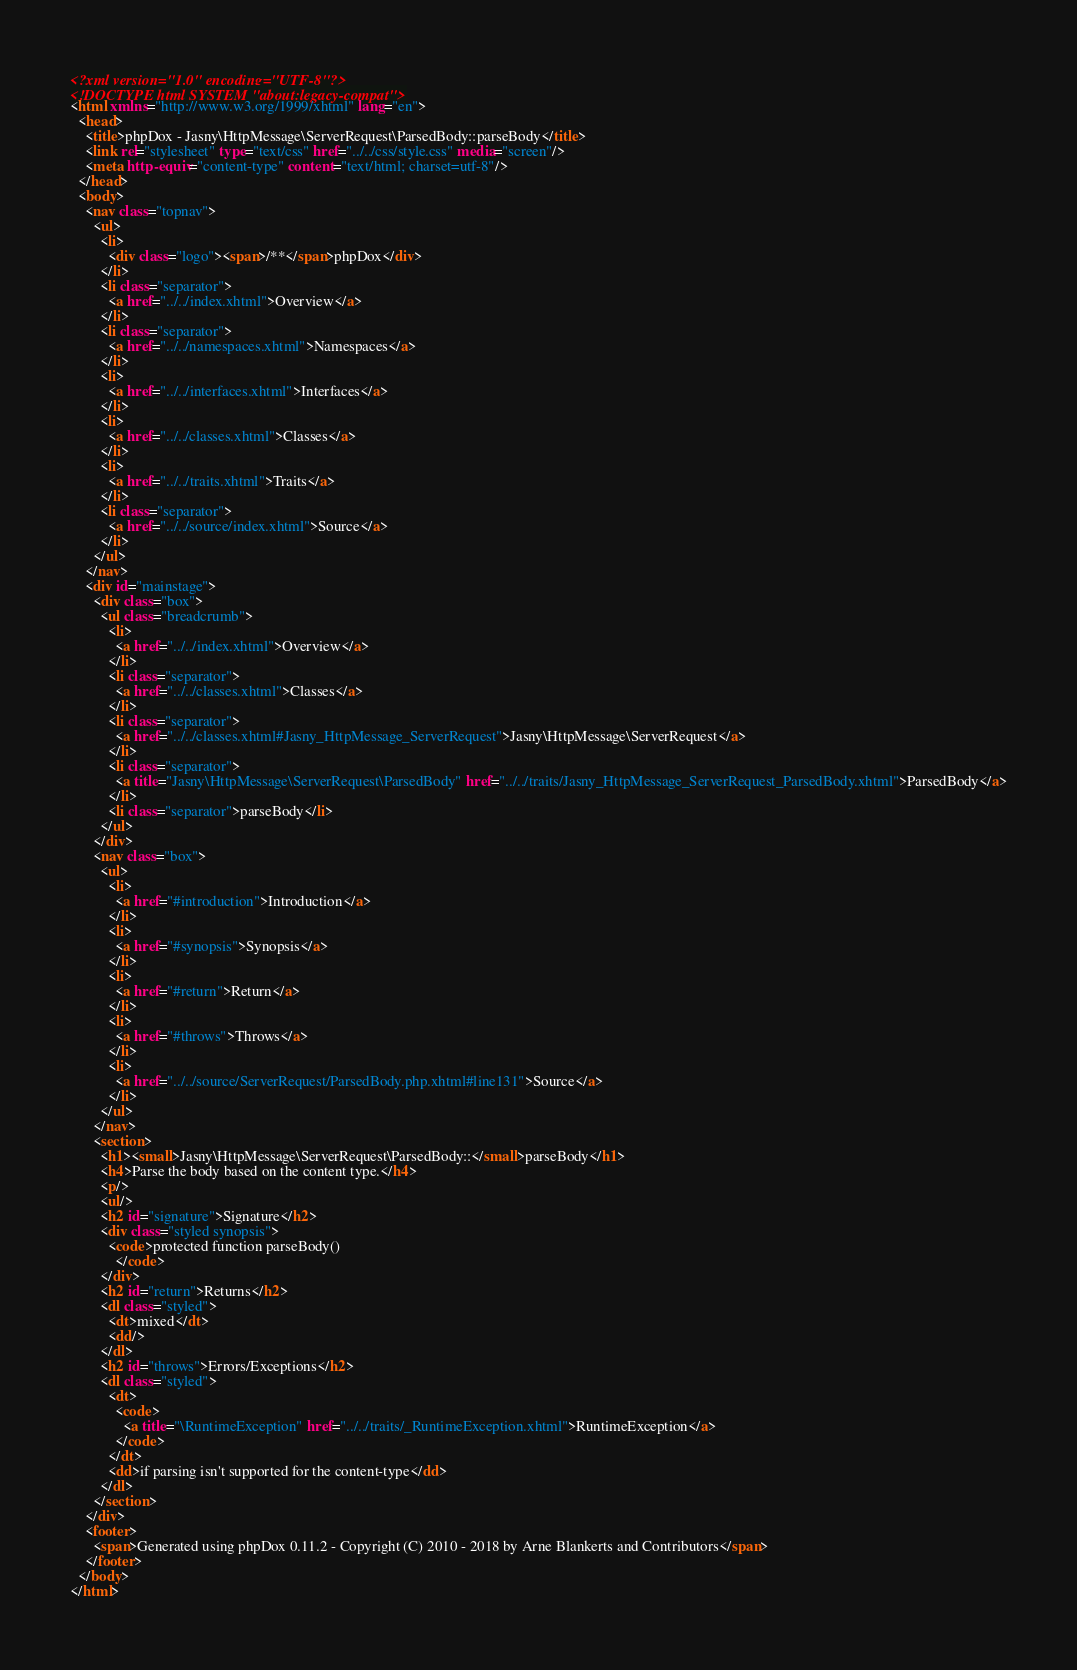Convert code to text. <code><loc_0><loc_0><loc_500><loc_500><_HTML_><?xml version="1.0" encoding="UTF-8"?>
<!DOCTYPE html SYSTEM "about:legacy-compat">
<html xmlns="http://www.w3.org/1999/xhtml" lang="en">
  <head>
    <title>phpDox - Jasny\HttpMessage\ServerRequest\ParsedBody::parseBody</title>
    <link rel="stylesheet" type="text/css" href="../../css/style.css" media="screen"/>
    <meta http-equiv="content-type" content="text/html; charset=utf-8"/>
  </head>
  <body>
    <nav class="topnav">
      <ul>
        <li>
          <div class="logo"><span>/**</span>phpDox</div>
        </li>
        <li class="separator">
          <a href="../../index.xhtml">Overview</a>
        </li>
        <li class="separator">
          <a href="../../namespaces.xhtml">Namespaces</a>
        </li>
        <li>
          <a href="../../interfaces.xhtml">Interfaces</a>
        </li>
        <li>
          <a href="../../classes.xhtml">Classes</a>
        </li>
        <li>
          <a href="../../traits.xhtml">Traits</a>
        </li>
        <li class="separator">
          <a href="../../source/index.xhtml">Source</a>
        </li>
      </ul>
    </nav>
    <div id="mainstage">
      <div class="box">
        <ul class="breadcrumb">
          <li>
            <a href="../../index.xhtml">Overview</a>
          </li>
          <li class="separator">
            <a href="../../classes.xhtml">Classes</a>
          </li>
          <li class="separator">
            <a href="../../classes.xhtml#Jasny_HttpMessage_ServerRequest">Jasny\HttpMessage\ServerRequest</a>
          </li>
          <li class="separator">
            <a title="Jasny\HttpMessage\ServerRequest\ParsedBody" href="../../traits/Jasny_HttpMessage_ServerRequest_ParsedBody.xhtml">ParsedBody</a>
          </li>
          <li class="separator">parseBody</li>
        </ul>
      </div>
      <nav class="box">
        <ul>
          <li>
            <a href="#introduction">Introduction</a>
          </li>
          <li>
            <a href="#synopsis">Synopsis</a>
          </li>
          <li>
            <a href="#return">Return</a>
          </li>
          <li>
            <a href="#throws">Throws</a>
          </li>
          <li>
            <a href="../../source/ServerRequest/ParsedBody.php.xhtml#line131">Source</a>
          </li>
        </ul>
      </nav>
      <section>
        <h1><small>Jasny\HttpMessage\ServerRequest\ParsedBody::</small>parseBody</h1>
        <h4>Parse the body based on the content type.</h4>
        <p/>
        <ul/>
        <h2 id="signature">Signature</h2>
        <div class="styled synopsis">
          <code>protected function parseBody()
            </code>
        </div>
        <h2 id="return">Returns</h2>
        <dl class="styled">
          <dt>mixed</dt>
          <dd/>
        </dl>
        <h2 id="throws">Errors/Exceptions</h2>
        <dl class="styled">
          <dt>
            <code>
              <a title="\RuntimeException" href="../../traits/_RuntimeException.xhtml">RuntimeException</a>
            </code>
          </dt>
          <dd>if parsing isn't supported for the content-type</dd>
        </dl>
      </section>
    </div>
    <footer>
      <span>Generated using phpDox 0.11.2 - Copyright (C) 2010 - 2018 by Arne Blankerts and Contributors</span>
    </footer>
  </body>
</html>
</code> 